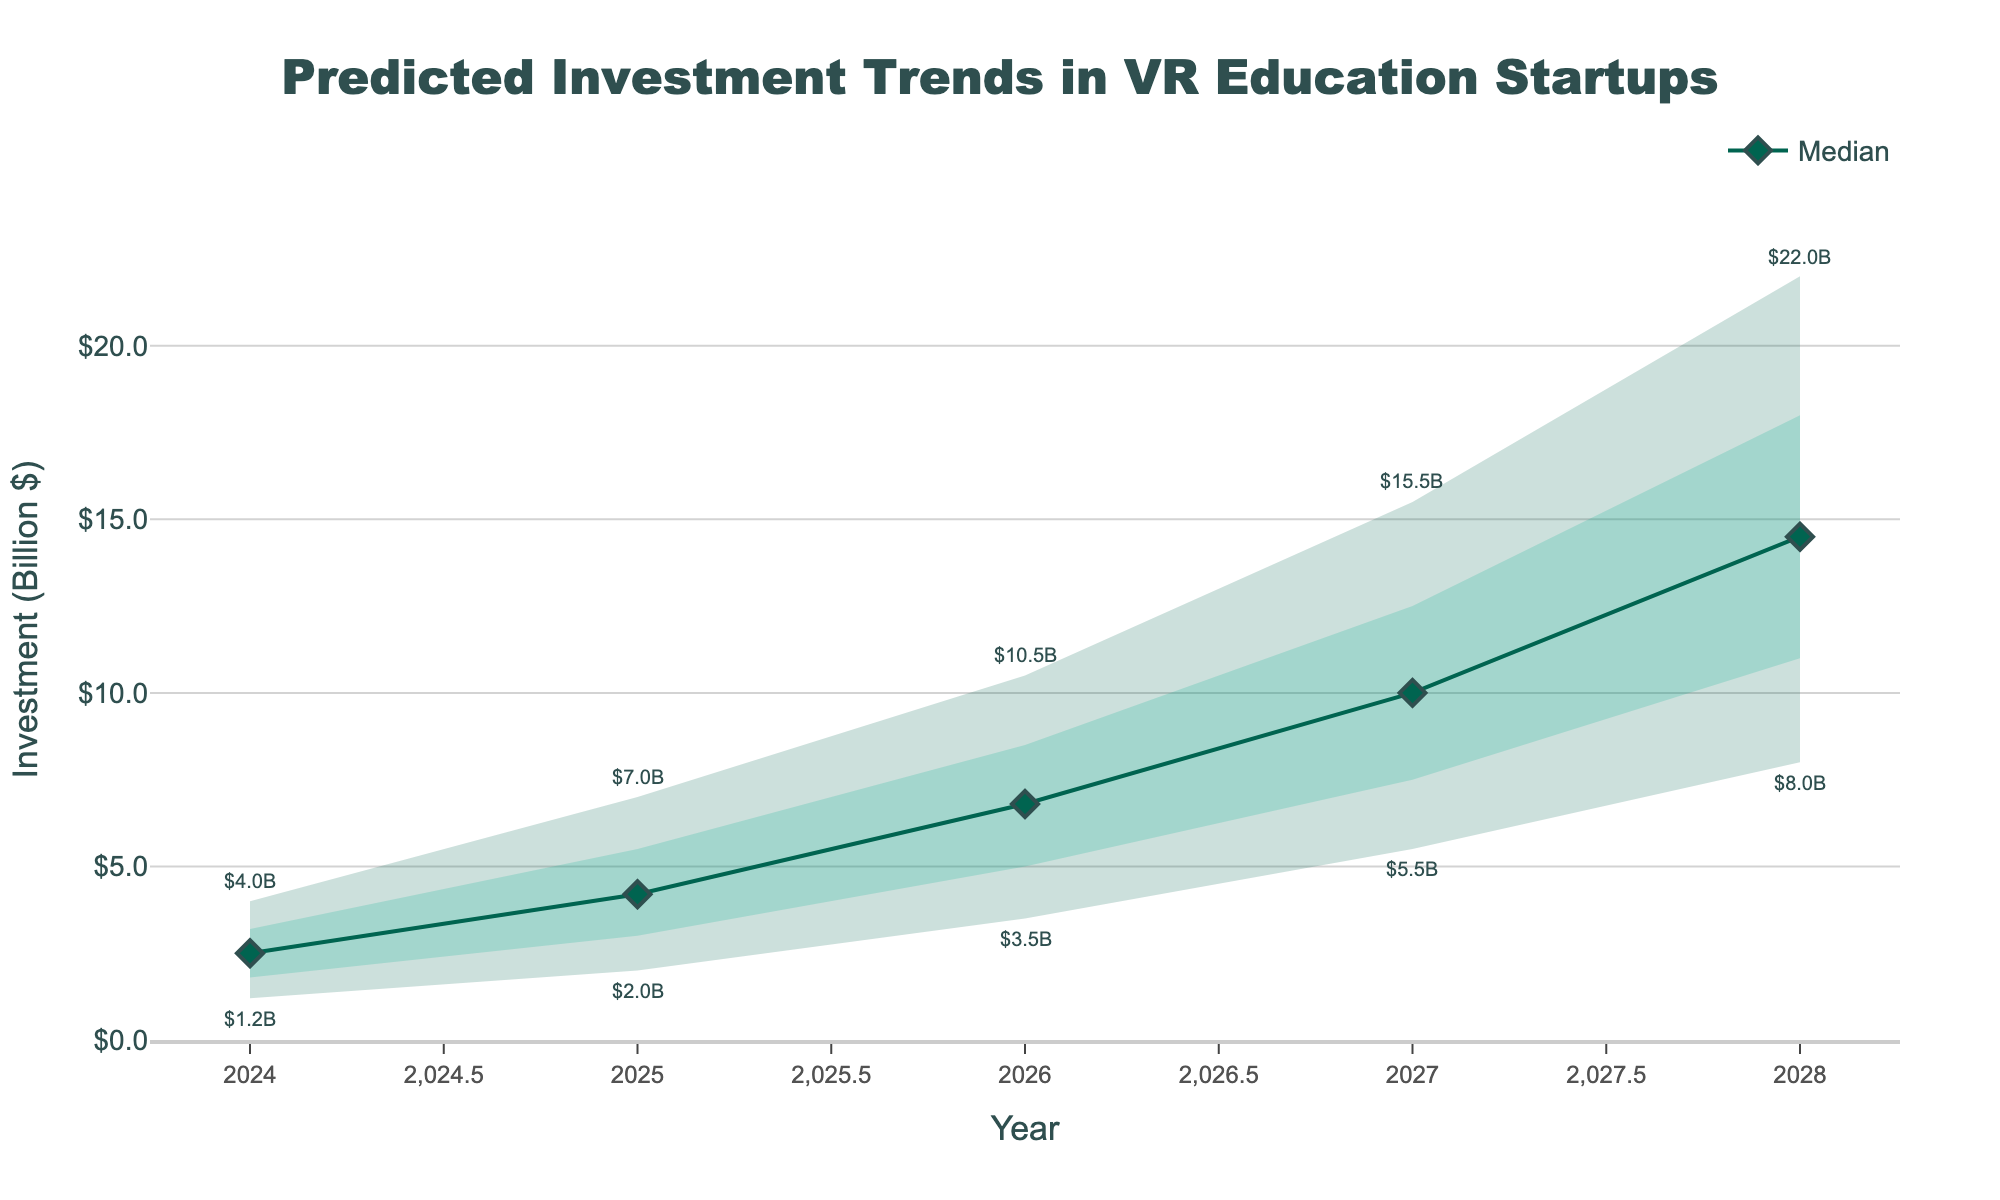what is the highest predicted investment in 2028? The highest predicted investment is found by looking at the "High" value for the year 2028, which is $22.0 billion.
Answer: $22.0 billion what is the median predicted investment for 2026? The median or middle value for the predicted investment in 2026 is found in the "Mid" column, which is $6.8 billion.
Answer: $6.8 billion if the actual investment in 2025 is $5 billion, where does that fall within the confidence intervals? To determine this, we compare $5 billion to the values in the "Low", "Low-Mid", "Mid-High", and "High" columns for 2025. $5 billion is between the "Mid" value of $4.2 billion and the "Mid-High" value of $5.5 billion.
Answer: Between Mid and Mid-High how does the predicted median investment change from 2024 to 2025? To find the change, subtract the median value of 2024 from that of 2025. The values are $4.2 billion in 2025 and $2.5 billion in 2024. $4.2 billion - $2.5 billion = $1.7 billion increase.
Answer: $1.7 billion increase which year shows the largest range in predicted investment values? The range is calculated as the difference between the "High" and "Low" values for each year. The year with the largest difference is 2028, with a range of $22.0 billion - $8.0 billion = $14.0 billion.
Answer: 2028 what trend do the median predicted investment values follow from 2024 to 2028? To determine the trend, observe the "Mid" values over the years: 2024 ($2.5B), 2025 ($4.2B), 2026 ($6.8B), 2027 ($10.0B), and 2028 ($14.5B). The values consistently increase each year, indicating a steadily upward trend.
Answer: Increasing trend how much greater is the predicted high investment in 2027 compared to 2025? The "High" value for 2027 is $15.5 billion, and for 2025 it is $7.0 billion. $15.5 billion - $7.0 billion = $8.5 billion.
Answer: $8.5 billion if investments hit the predicted mid-high value in 2026, what will be the percent increase from the mid value in 2024? The mid-high value for 2026 is $8.5 billion, and the mid value for 2024 is $2.5 billion. The percent increase is calculated as (($8.5B - $2.5B) / $2.5B) * 100%, which equals 240%.
Answer: 240% what is indicated by the shaded areas in the chart? The shaded areas represent the confidence intervals for the predicted investment values. The inner bands show more likely ranges (Low-Mid to Mid-High) while the outer bands show broader ranges of possible values (Low to High).
Answer: Confidence intervals 